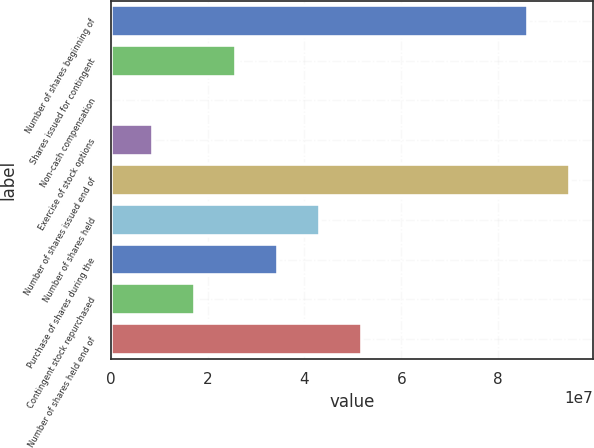<chart> <loc_0><loc_0><loc_500><loc_500><bar_chart><fcel>Number of shares beginning of<fcel>Shares issued for contingent<fcel>Non-cash compensation<fcel>Exercise of stock options<fcel>Number of shares issued end of<fcel>Number of shares held<fcel>Purchase of shares during the<fcel>Contingent stock repurchased<fcel>Number of shares held end of<nl><fcel>8.61427e+07<fcel>2.59502e+07<fcel>4983<fcel>8.65338e+06<fcel>9.47911e+07<fcel>4.32469e+07<fcel>3.45986e+07<fcel>1.73018e+07<fcel>5.18953e+07<nl></chart> 